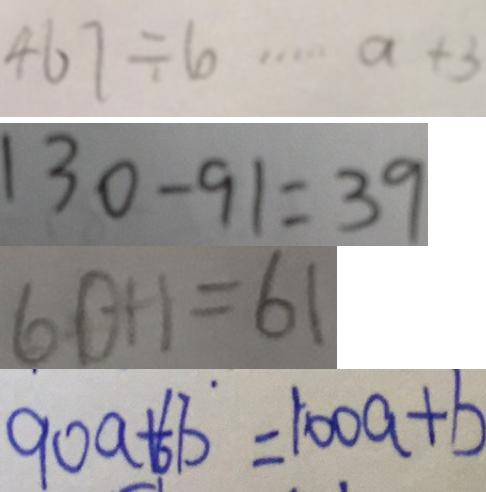Convert formula to latex. <formula><loc_0><loc_0><loc_500><loc_500>4 6 7 \div 6 \cdots a + 3 
 1 3 0 - 9 1 = 3 9 
 6 0 + 1 = 6 1 
 9 0 a + 6 b ^ { \cdot } = 1 0 0 a + b</formula> 